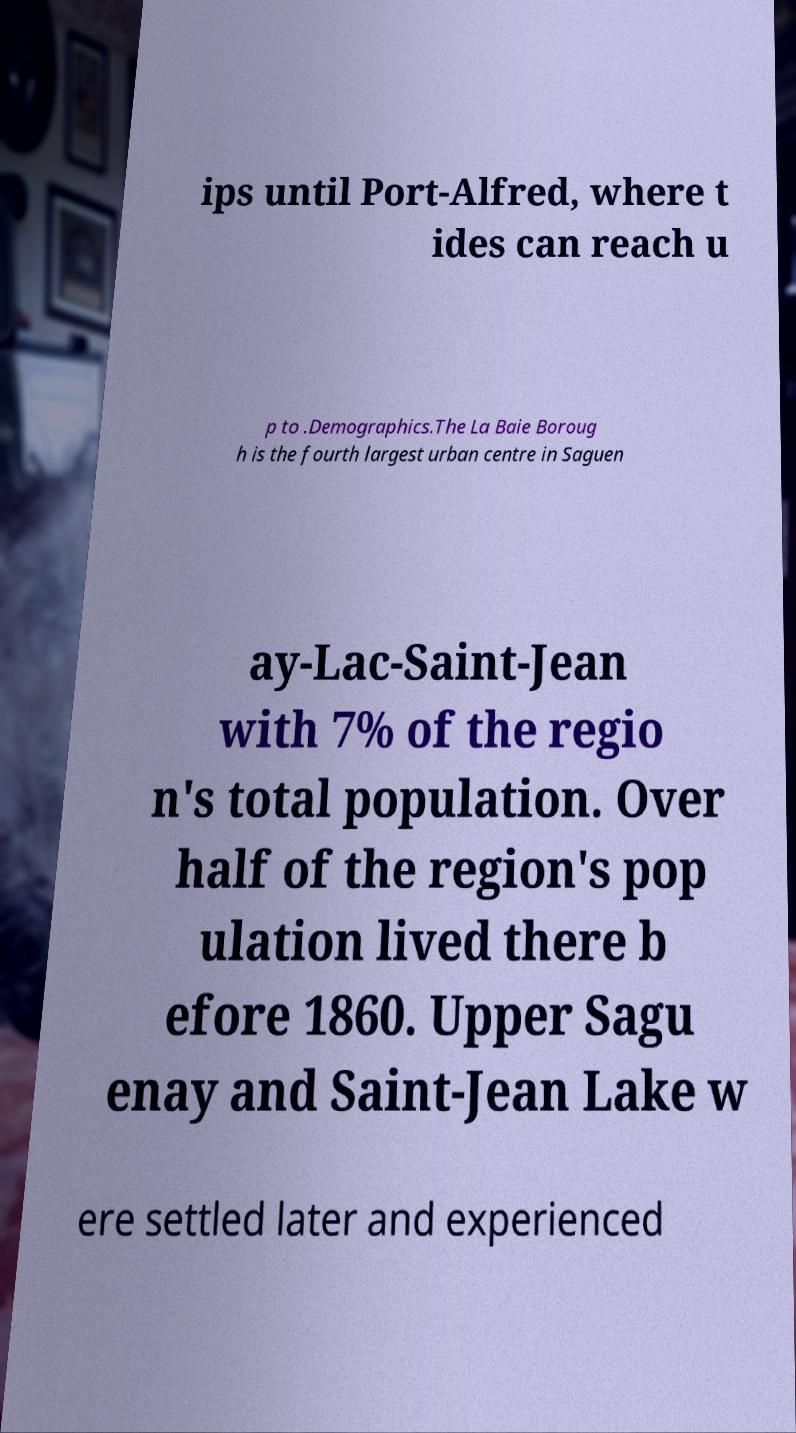Could you extract and type out the text from this image? ips until Port-Alfred, where t ides can reach u p to .Demographics.The La Baie Boroug h is the fourth largest urban centre in Saguen ay-Lac-Saint-Jean with 7% of the regio n's total population. Over half of the region's pop ulation lived there b efore 1860. Upper Sagu enay and Saint-Jean Lake w ere settled later and experienced 